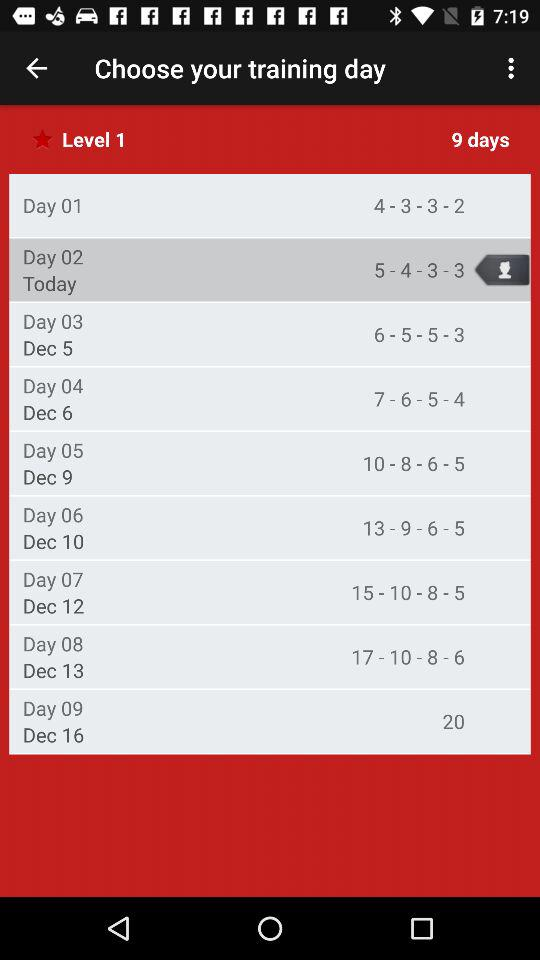Which level of training is it? The level of training is 1. 